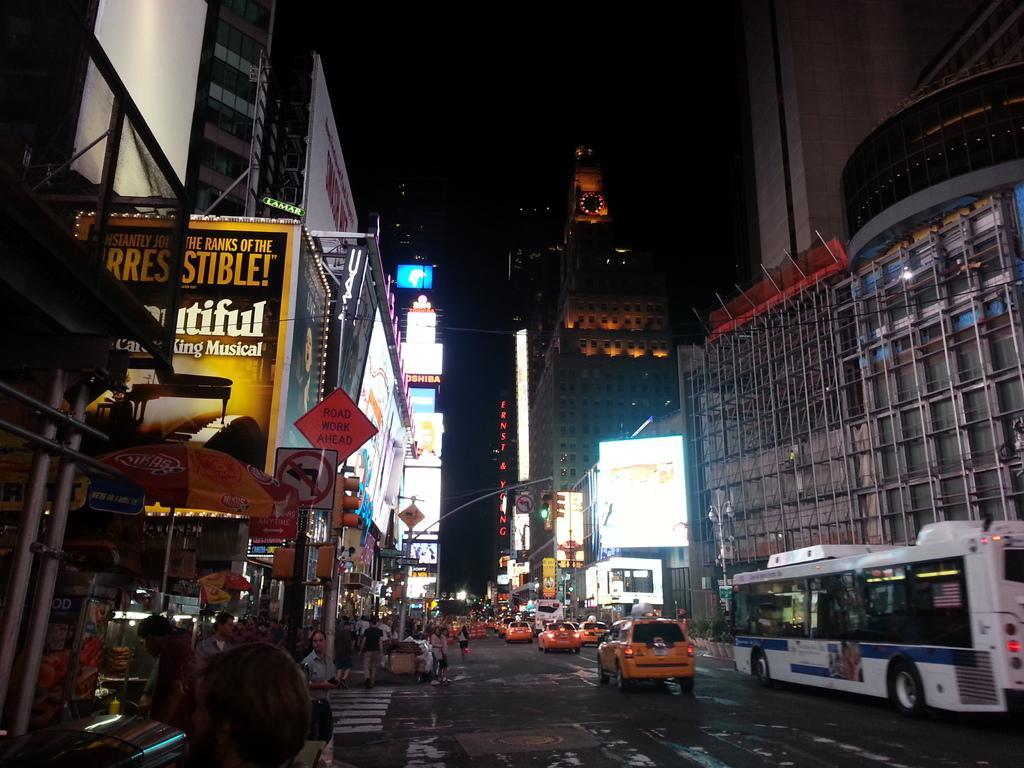Describe this image in one or two sentences. In this image there are vehicles passing on the road, beside the road on the pavement there are a few pedestrians walking and there are sign boards and lamp posts. In the background of the image there are buildings, in front of the buildings there are shops with name boards, in front of the buildings there are tents and there are billboards on the buildings. 